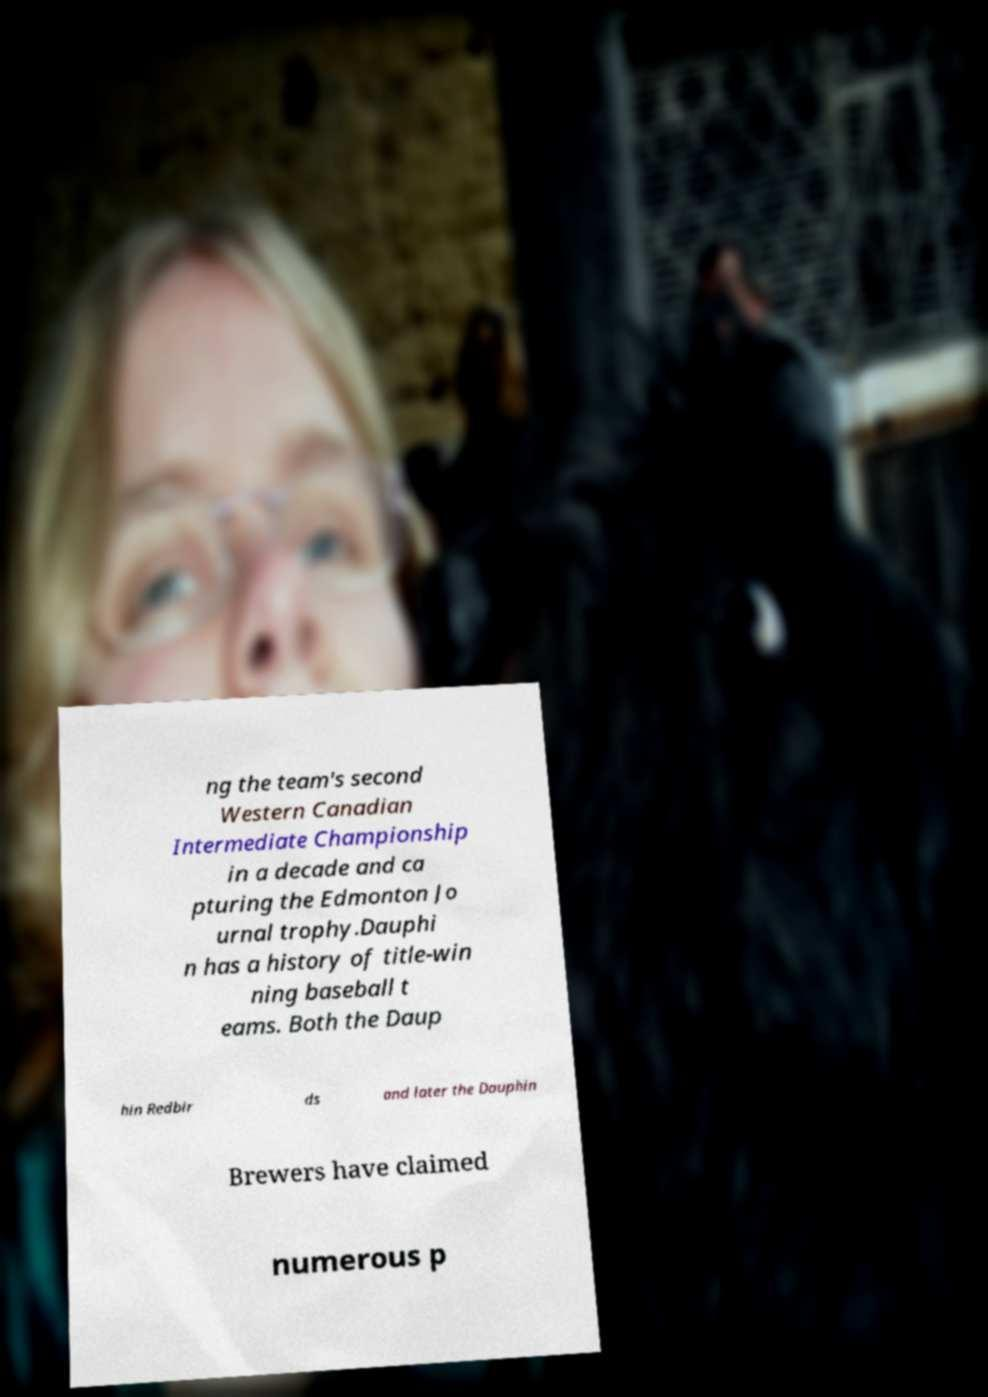What messages or text are displayed in this image? I need them in a readable, typed format. ng the team's second Western Canadian Intermediate Championship in a decade and ca pturing the Edmonton Jo urnal trophy.Dauphi n has a history of title-win ning baseball t eams. Both the Daup hin Redbir ds and later the Dauphin Brewers have claimed numerous p 